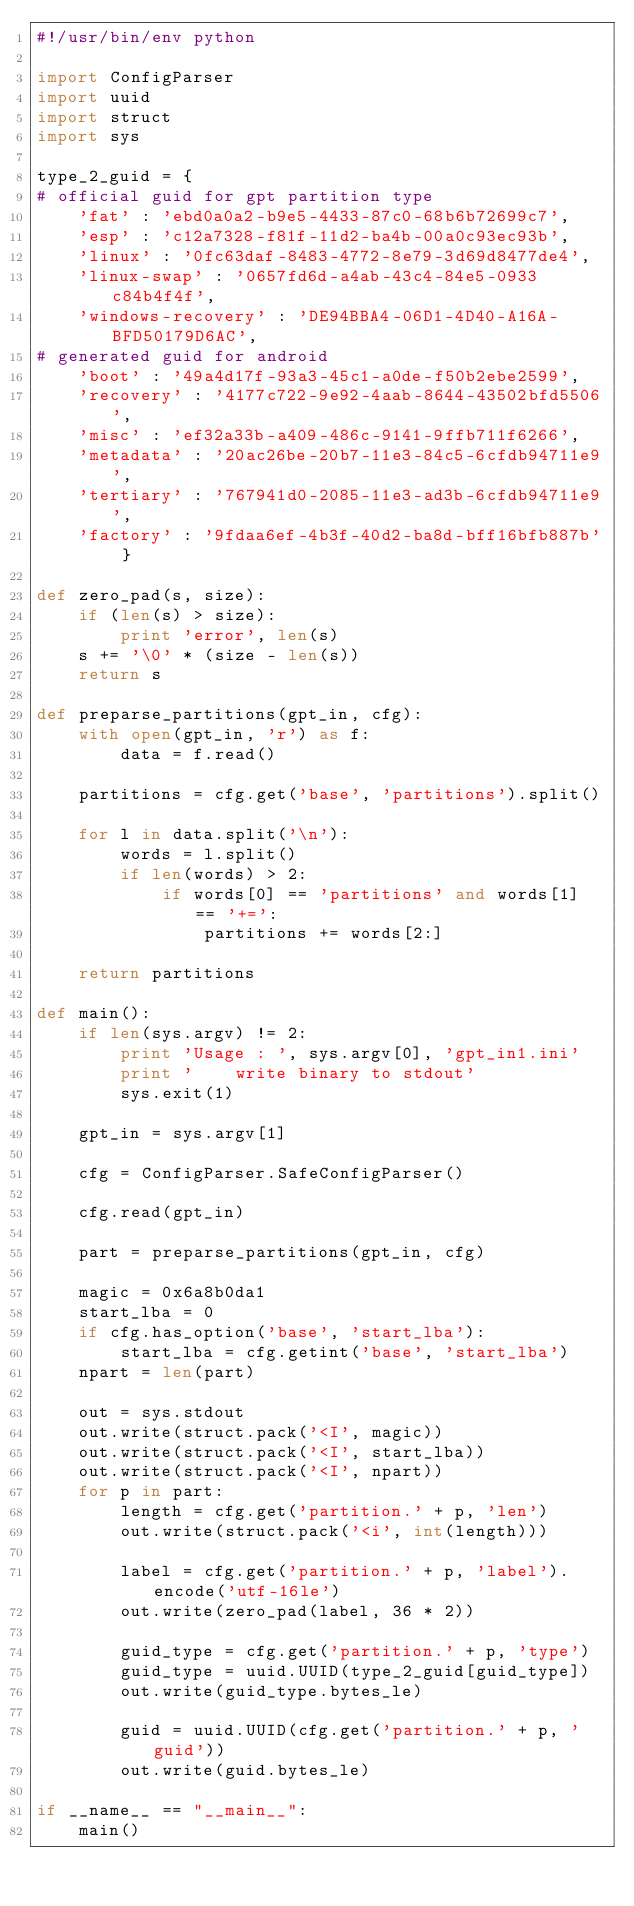Convert code to text. <code><loc_0><loc_0><loc_500><loc_500><_Python_>#!/usr/bin/env python

import ConfigParser
import uuid
import struct
import sys

type_2_guid = {
# official guid for gpt partition type
    'fat' : 'ebd0a0a2-b9e5-4433-87c0-68b6b72699c7',
    'esp' : 'c12a7328-f81f-11d2-ba4b-00a0c93ec93b',
    'linux' : '0fc63daf-8483-4772-8e79-3d69d8477de4',
    'linux-swap' : '0657fd6d-a4ab-43c4-84e5-0933c84b4f4f',
    'windows-recovery' : 'DE94BBA4-06D1-4D40-A16A-BFD50179D6AC',
# generated guid for android
    'boot' : '49a4d17f-93a3-45c1-a0de-f50b2ebe2599',
    'recovery' : '4177c722-9e92-4aab-8644-43502bfd5506',
    'misc' : 'ef32a33b-a409-486c-9141-9ffb711f6266',
    'metadata' : '20ac26be-20b7-11e3-84c5-6cfdb94711e9',
    'tertiary' : '767941d0-2085-11e3-ad3b-6cfdb94711e9',
    'factory' : '9fdaa6ef-4b3f-40d2-ba8d-bff16bfb887b' }

def zero_pad(s, size):
    if (len(s) > size):
        print 'error', len(s)
    s += '\0' * (size - len(s))
    return s

def preparse_partitions(gpt_in, cfg):
    with open(gpt_in, 'r') as f:
        data = f.read()

    partitions = cfg.get('base', 'partitions').split()

    for l in data.split('\n'):
        words = l.split()
        if len(words) > 2:
            if words[0] == 'partitions' and words[1] == '+=':
                partitions += words[2:]

    return partitions

def main():
    if len(sys.argv) != 2:
        print 'Usage : ', sys.argv[0], 'gpt_in1.ini'
        print '    write binary to stdout'
        sys.exit(1)

    gpt_in = sys.argv[1]

    cfg = ConfigParser.SafeConfigParser()

    cfg.read(gpt_in)

    part = preparse_partitions(gpt_in, cfg)

    magic = 0x6a8b0da1
    start_lba = 0
    if cfg.has_option('base', 'start_lba'):
        start_lba = cfg.getint('base', 'start_lba')
    npart = len(part)

    out = sys.stdout
    out.write(struct.pack('<I', magic))
    out.write(struct.pack('<I', start_lba))
    out.write(struct.pack('<I', npart))
    for p in part:
        length = cfg.get('partition.' + p, 'len')
        out.write(struct.pack('<i', int(length)))

        label = cfg.get('partition.' + p, 'label').encode('utf-16le')
        out.write(zero_pad(label, 36 * 2))

        guid_type = cfg.get('partition.' + p, 'type')
        guid_type = uuid.UUID(type_2_guid[guid_type])
        out.write(guid_type.bytes_le)

        guid = uuid.UUID(cfg.get('partition.' + p, 'guid'))
        out.write(guid.bytes_le)

if __name__ == "__main__":
    main()
</code> 